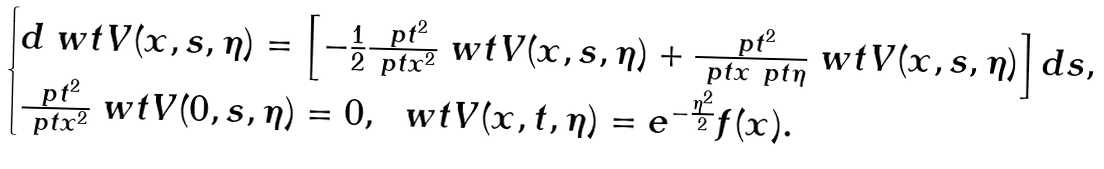<formula> <loc_0><loc_0><loc_500><loc_500>\begin{cases} d \ w t { V } ( x , s , \eta ) = \left [ - \frac { 1 } { 2 } \frac { \ p t ^ { 2 } } { \ p t x ^ { 2 } } \ w t { V } ( x , s , \eta ) + \frac { \ p t ^ { 2 } } { \ p t x \ p t \eta } \ w t { V } ( x , s , \eta ) \right ] d s , \\ \frac { \ p t ^ { 2 } } { \ p t x ^ { 2 } } \ w t { V } ( 0 , s , \eta ) = 0 , \ \ w t { V } ( x , t , \eta ) = e ^ { - \frac { \eta ^ { 2 } } { 2 } } f ( x ) . \end{cases}</formula> 